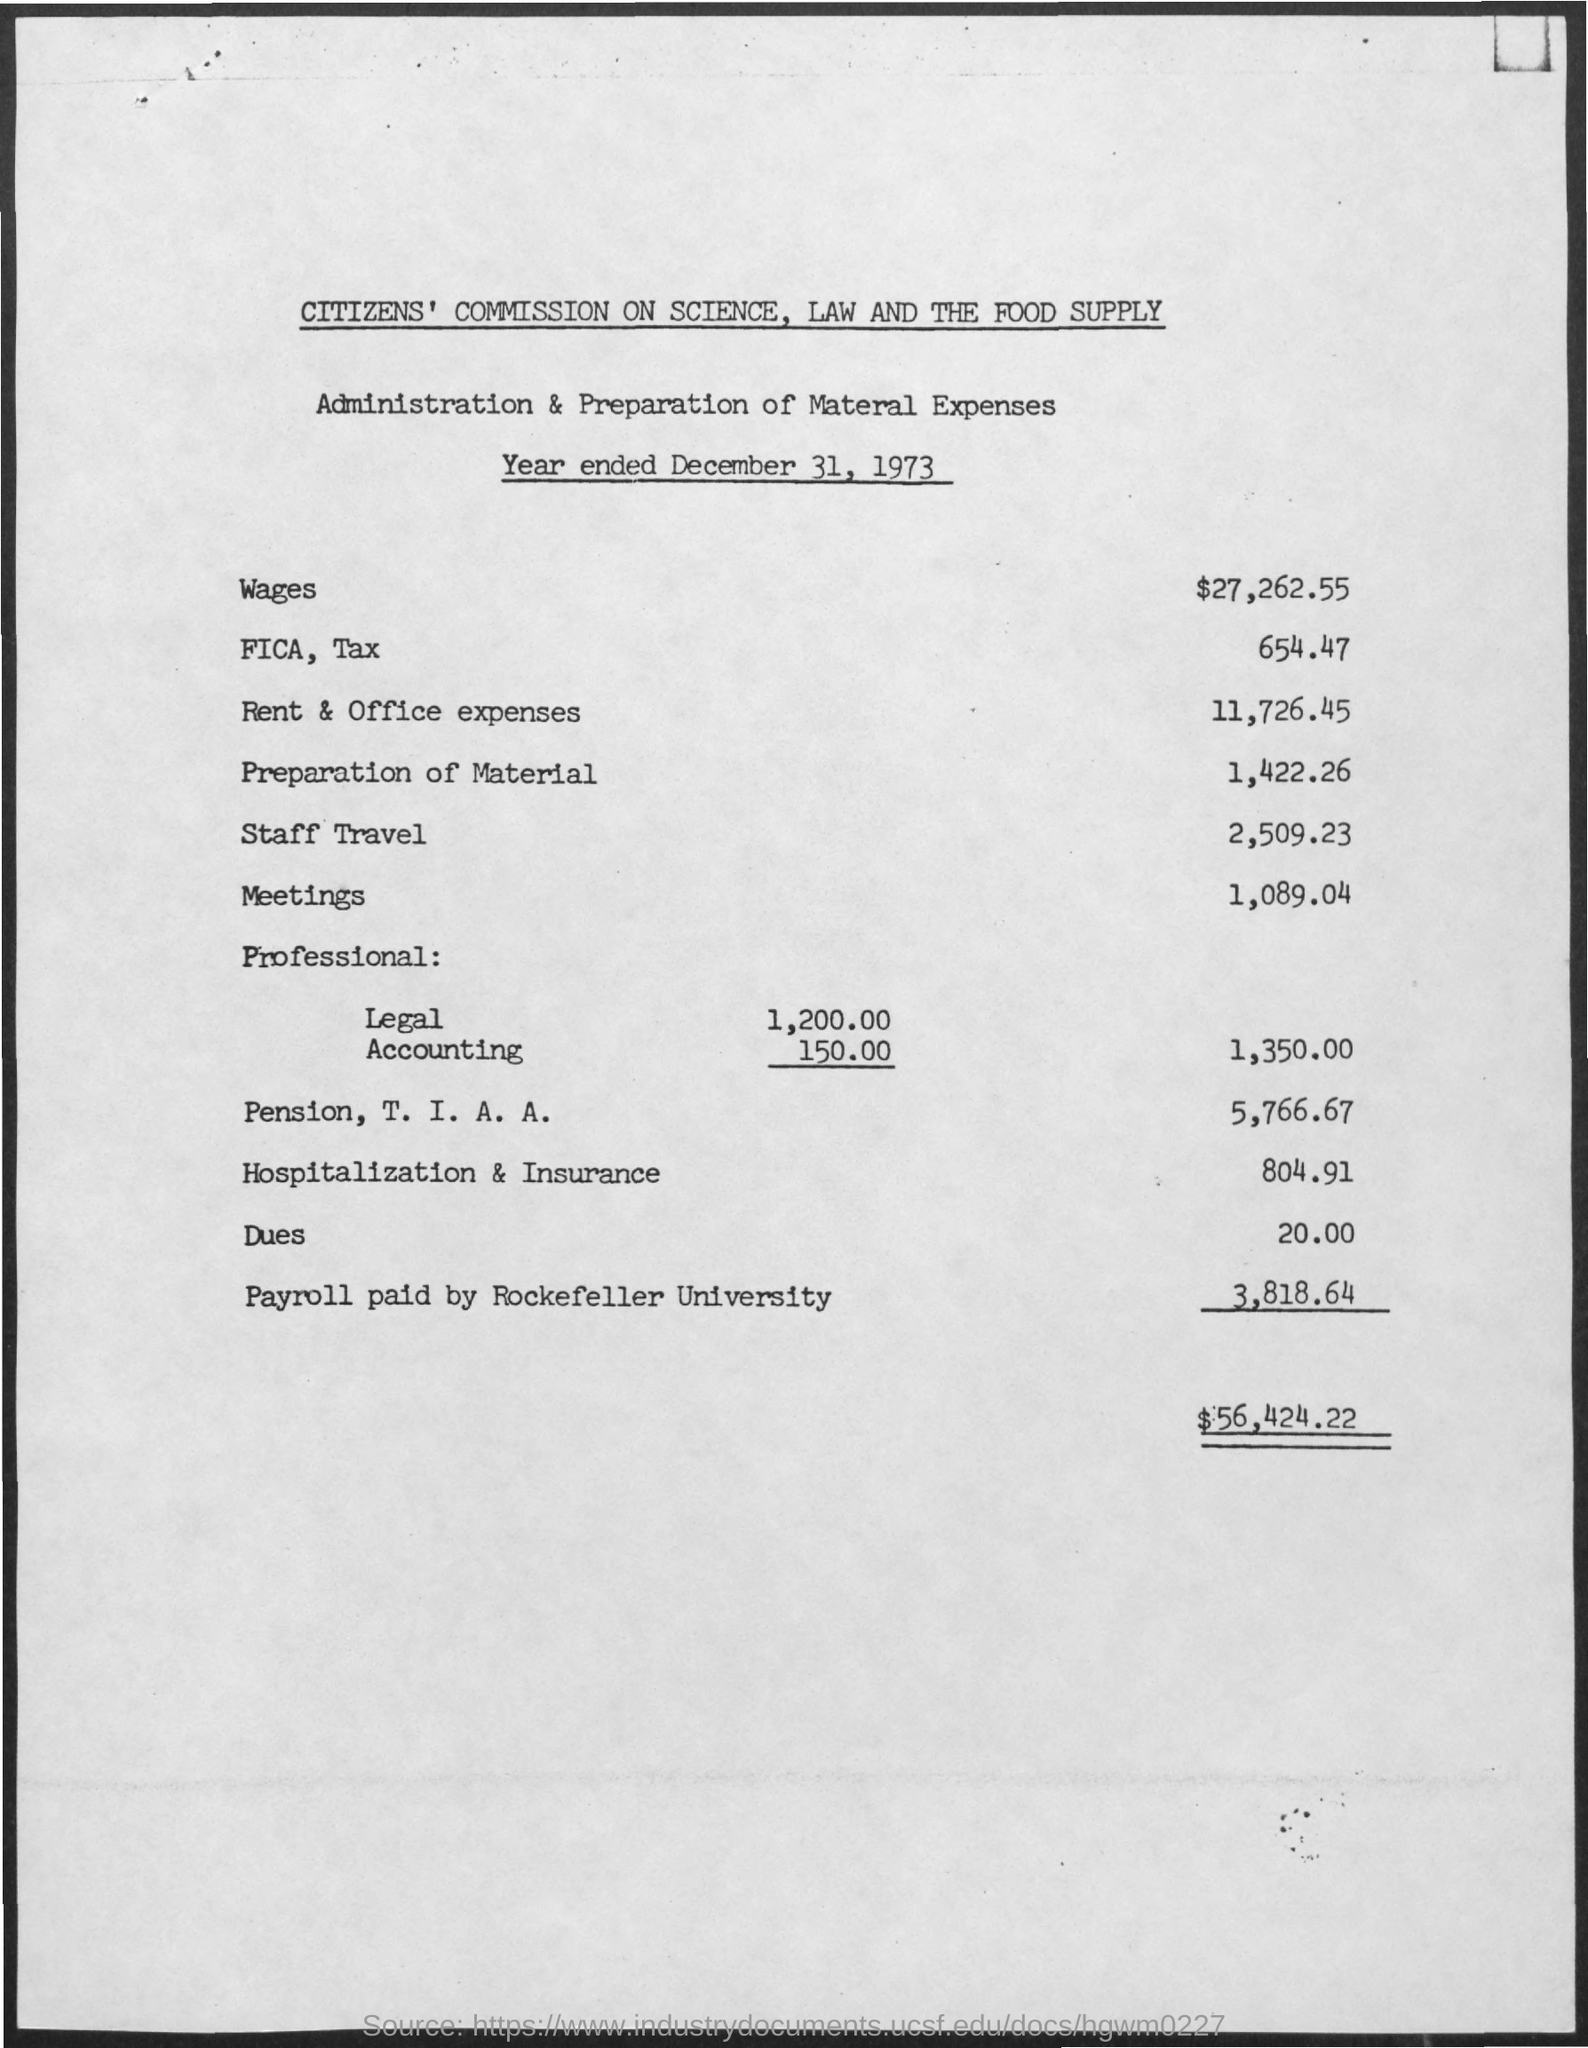What are the wages for the year ended December 31, 1973?
Provide a short and direct response. $27,262.55. What are the Rent & Office Expenses for the year ended December 31, 1973?
Provide a short and direct response. $11,726.45. What is the Expense for Preparation of Material for the year ended December 31, 1973?
Keep it short and to the point. $1,422.26. What are the staff travel expenses for the year ended December 31, 1973?
Your answer should be compact. $2,509.23. What are the meeting expenses for the year ended December 31, 1973?
Make the answer very short. $1,089.04. How much is the Payroll paid by Rockefeller University for the year ended December 31, 1973?
Your answer should be very brief. $3,818.64. What are the Hospitalization & Insurance Expenses for the year ended December 31, 1973?
Give a very brief answer. $ 804.91. What are the Total Administration & Preparation Expenses for the year ended December 31, 1973?
Offer a terse response. $56,424.22. 